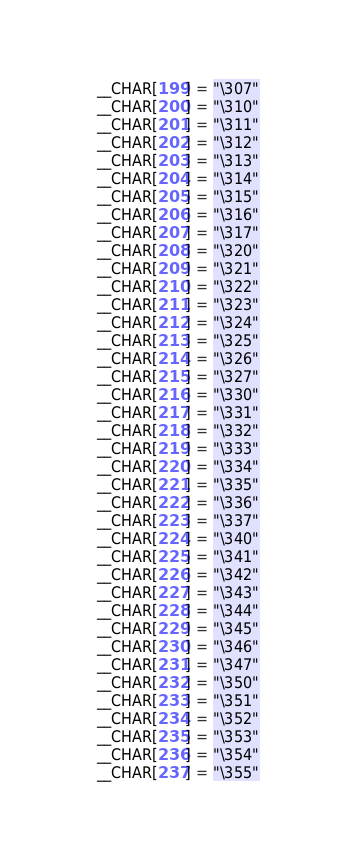<code> <loc_0><loc_0><loc_500><loc_500><_Awk_>	__CHAR[199] = "\307"
	__CHAR[200] = "\310"
	__CHAR[201] = "\311"
	__CHAR[202] = "\312"
	__CHAR[203] = "\313"
	__CHAR[204] = "\314"
	__CHAR[205] = "\315"
	__CHAR[206] = "\316"
	__CHAR[207] = "\317"
	__CHAR[208] = "\320"
	__CHAR[209] = "\321"
	__CHAR[210] = "\322"
	__CHAR[211] = "\323"
	__CHAR[212] = "\324"
	__CHAR[213] = "\325"
	__CHAR[214] = "\326"
	__CHAR[215] = "\327"
	__CHAR[216] = "\330"
	__CHAR[217] = "\331"
	__CHAR[218] = "\332"
	__CHAR[219] = "\333"
	__CHAR[220] = "\334"
	__CHAR[221] = "\335"
	__CHAR[222] = "\336"
	__CHAR[223] = "\337"
	__CHAR[224] = "\340"
	__CHAR[225] = "\341"
	__CHAR[226] = "\342"
	__CHAR[227] = "\343"
	__CHAR[228] = "\344"
	__CHAR[229] = "\345"
	__CHAR[230] = "\346"
	__CHAR[231] = "\347"
	__CHAR[232] = "\350"
	__CHAR[233] = "\351"
	__CHAR[234] = "\352"
	__CHAR[235] = "\353"
	__CHAR[236] = "\354"
	__CHAR[237] = "\355"</code> 